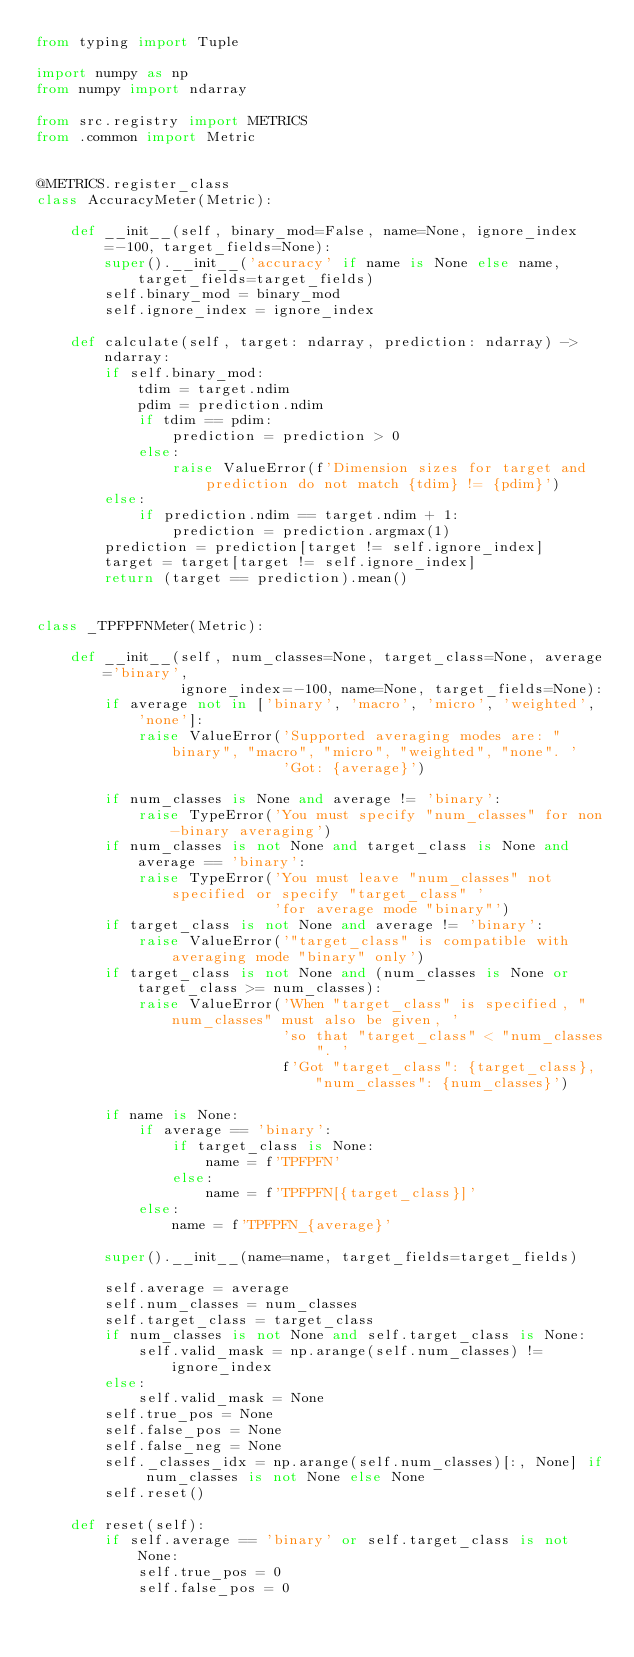Convert code to text. <code><loc_0><loc_0><loc_500><loc_500><_Python_>from typing import Tuple

import numpy as np
from numpy import ndarray

from src.registry import METRICS
from .common import Metric


@METRICS.register_class
class AccuracyMeter(Metric):

    def __init__(self, binary_mod=False, name=None, ignore_index=-100, target_fields=None):
        super().__init__('accuracy' if name is None else name, target_fields=target_fields)
        self.binary_mod = binary_mod
        self.ignore_index = ignore_index

    def calculate(self, target: ndarray, prediction: ndarray) -> ndarray:
        if self.binary_mod:
            tdim = target.ndim
            pdim = prediction.ndim
            if tdim == pdim:
                prediction = prediction > 0
            else:
                raise ValueError(f'Dimension sizes for target and prediction do not match {tdim} != {pdim}')
        else:
            if prediction.ndim == target.ndim + 1:
                prediction = prediction.argmax(1)
        prediction = prediction[target != self.ignore_index]
        target = target[target != self.ignore_index]
        return (target == prediction).mean()


class _TPFPFNMeter(Metric):

    def __init__(self, num_classes=None, target_class=None, average='binary',
                 ignore_index=-100, name=None, target_fields=None):
        if average not in ['binary', 'macro', 'micro', 'weighted', 'none']:
            raise ValueError('Supported averaging modes are: "binary", "macro", "micro", "weighted", "none". '
                             'Got: {average}')

        if num_classes is None and average != 'binary':
            raise TypeError('You must specify "num_classes" for non-binary averaging')
        if num_classes is not None and target_class is None and average == 'binary':
            raise TypeError('You must leave "num_classes" not specified or specify "target_class" '
                            'for average mode "binary"')
        if target_class is not None and average != 'binary':
            raise ValueError('"target_class" is compatible with averaging mode "binary" only')
        if target_class is not None and (num_classes is None or target_class >= num_classes):
            raise ValueError('When "target_class" is specified, "num_classes" must also be given, '
                             'so that "target_class" < "num_classes". '
                             f'Got "target_class": {target_class}, "num_classes": {num_classes}')

        if name is None:
            if average == 'binary':
                if target_class is None:
                    name = f'TPFPFN'
                else:
                    name = f'TPFPFN[{target_class}]'
            else:
                name = f'TPFPFN_{average}'

        super().__init__(name=name, target_fields=target_fields)

        self.average = average
        self.num_classes = num_classes
        self.target_class = target_class
        if num_classes is not None and self.target_class is None:
            self.valid_mask = np.arange(self.num_classes) != ignore_index
        else:
            self.valid_mask = None
        self.true_pos = None
        self.false_pos = None
        self.false_neg = None
        self._classes_idx = np.arange(self.num_classes)[:, None] if num_classes is not None else None
        self.reset()

    def reset(self):
        if self.average == 'binary' or self.target_class is not None:
            self.true_pos = 0
            self.false_pos = 0</code> 